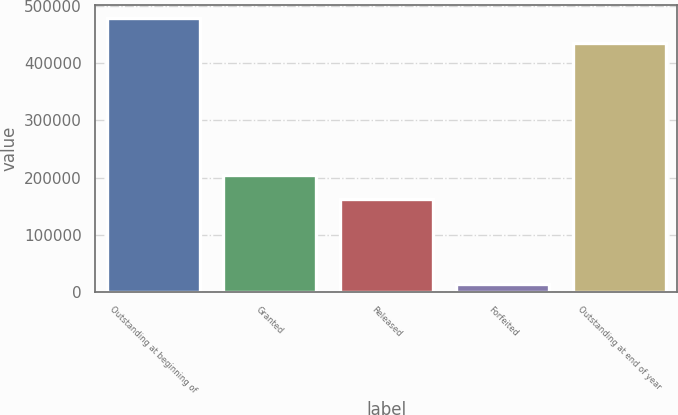Convert chart to OTSL. <chart><loc_0><loc_0><loc_500><loc_500><bar_chart><fcel>Outstanding at beginning of<fcel>Granted<fcel>Released<fcel>Forfeited<fcel>Outstanding at end of year<nl><fcel>478361<fcel>204960<fcel>161976<fcel>14524<fcel>435377<nl></chart> 